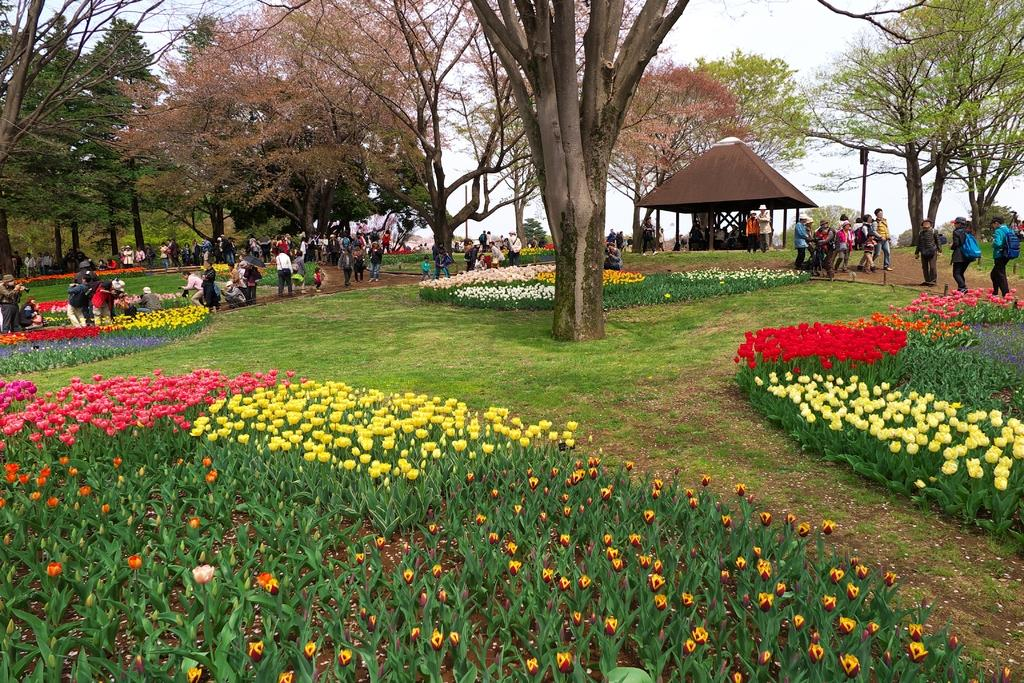What type of location is shown in the image? The image depicts a garden. What colors of flowers can be seen in the garden? There are pink, yellow, orange, red, and white flowers in the garden. What other features are present in the garden? There are many trees in the garden. What are the people in the image doing? People are standing and walking in the garden. What type of comb is being used to groom the flowers in the garden? There is no comb present in the image, and flowers do not require grooming. What rule is being enforced by the people walking in the garden? There is no rule mentioned or implied in the image; people are simply walking in the garden. 